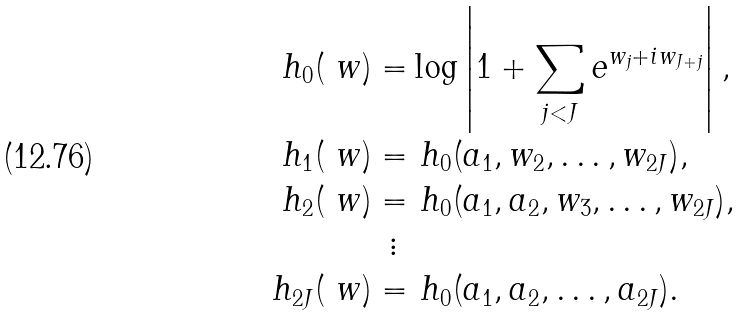<formula> <loc_0><loc_0><loc_500><loc_500>h _ { 0 } ( \ w ) = & \log \left | 1 + \sum _ { j < J } e ^ { w _ { j } + i w _ { J + j } } \right | , \\ h _ { 1 } ( \ w ) = & \ h _ { 0 } ( a _ { 1 } , w _ { 2 } , \dots , w _ { 2 J } ) , \\ h _ { 2 } ( \ w ) = & \ h _ { 0 } ( a _ { 1 } , a _ { 2 } , w _ { 3 } , \dots , w _ { 2 J } ) , \\ \vdots \ & \\ h _ { 2 J } ( \ w ) = & \ h _ { 0 } ( a _ { 1 } , a _ { 2 } , \dots , a _ { 2 J } ) .</formula> 